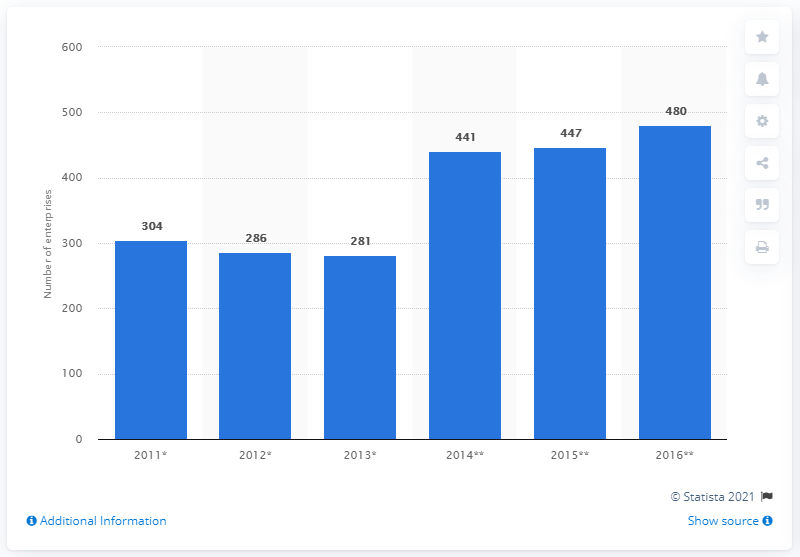List a handful of essential elements in this visual. In 2016, there were 480 enterprises in the plastics products industry in Bosnia and Herzegovina. 